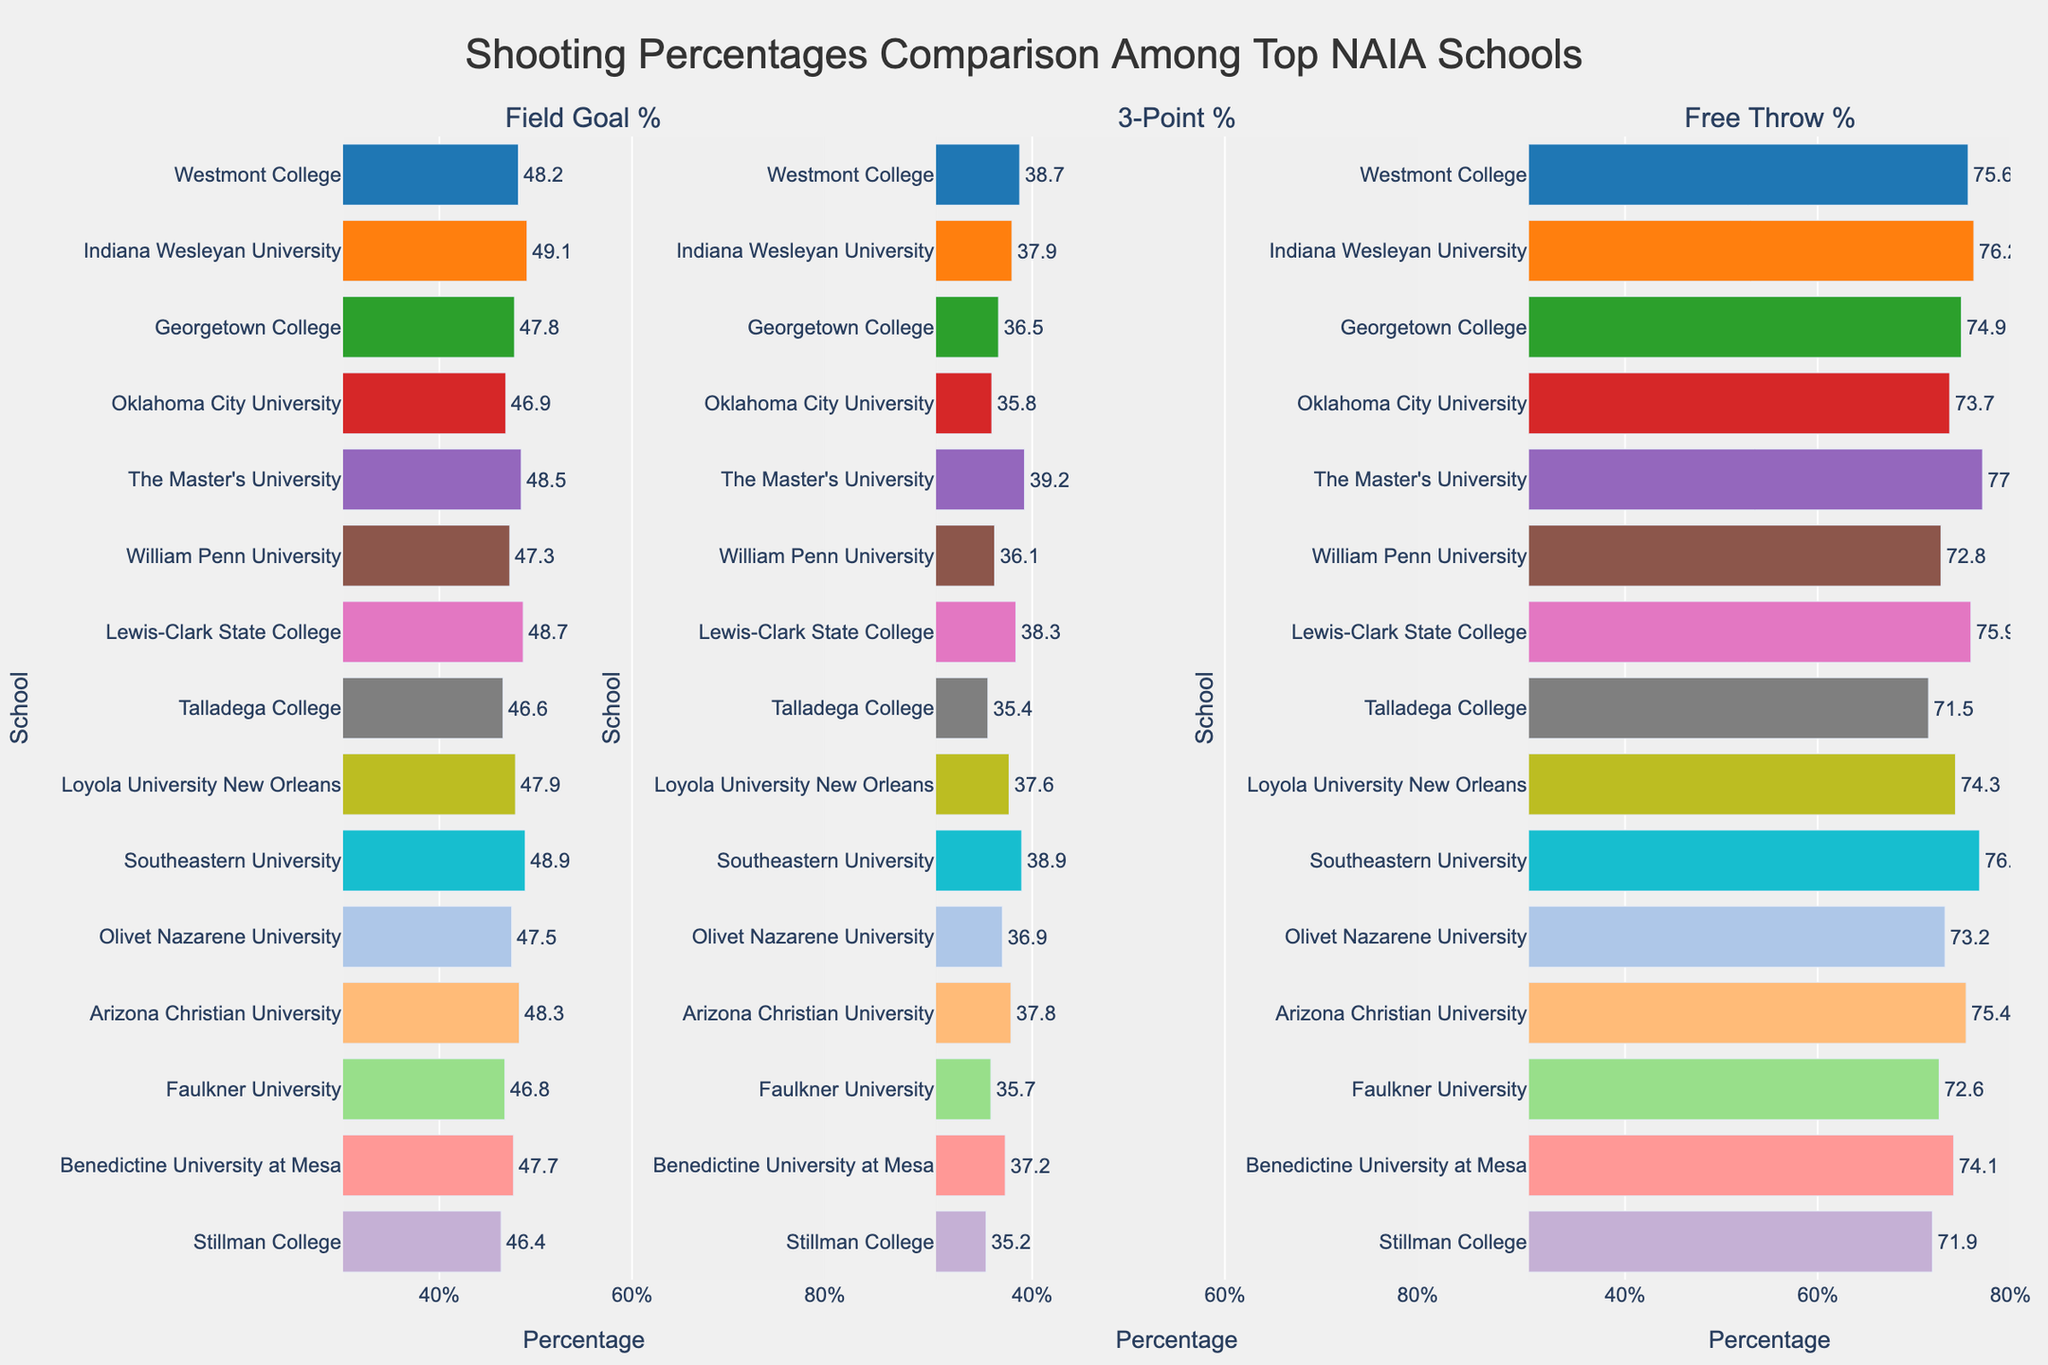Which school has the highest field goal percentage? Look at the Field Goal % bar and identify the school with the longest bar. Indiana Wesleyan University has the highest field goal percentage.
Answer: Indiana Wesleyan University Which school has the lowest 3-point percentage? Look at the 3-Point % bar and identify the school with the shortest bar. Stillman College has the lowest 3-point percentage.
Answer: Stillman College Which two schools have nearly the same free throw percentage, and what is that percentage? Look at the Free Throw % bars and find two bars that have similar lengths. The Master's University and Southeastern University both have free throw percentages around 77.1% and 76.8% respectively.
Answer: The Master's University and Southeastern University, ~77% What is the difference in field goal percentage between Westmont College and Oklahoma City University? Find the field goal percentages for Westmont College (48.2%) and Oklahoma City University (46.9%) and calculate the difference: 48.2% - 46.9% = 1.3%.
Answer: 1.3% Which school has the second highest 3-point percentage? Look at the 3-Point % bar and identify the school with the second longest bar. Southeastern University has the second highest 3-point percentage.
Answer: Southeastern University What is the average 3-point percentage among the top NAIA schools? Add all the 3-point percentages and divide by the number of schools: (38.7 + 37.9 + 36.5 + 35.8 + 39.2 + 36.1 + 38.3 + 35.4 + 37.6 + 38.9 + 36.9 + 37.8 + 35.7 + 37.2 + 35.2) / 15 = 36.9%.
Answer: 36.9% Which school has a better free throw percentage: Faulkner University or Benedictine University at Mesa? Compare the free throw percentages of Faulkner University (72.6%) and Benedictine University at Mesa (74.1%). Benedictine University at Mesa has a better free throw percentage.
Answer: Benedictine University at Mesa If you combined the free throw percentages of Loyola University New Orleans and Stillman College, what would be the total percentage? Add the free throw percentages of the two schools: 74.3% + 71.9% = 146.2%.
Answer: 146.2% Which school has a higher field goal percentage: Olivet Nazarene University or Arizona Christian University, and by how much? Compare the field goal percentages of Olivet Nazarene University (47.5%) and Arizona Christian University (48.3%), and calculate the difference: 48.3% - 47.5% = 0.8%.
Answer: Arizona Christian University, 0.8% 